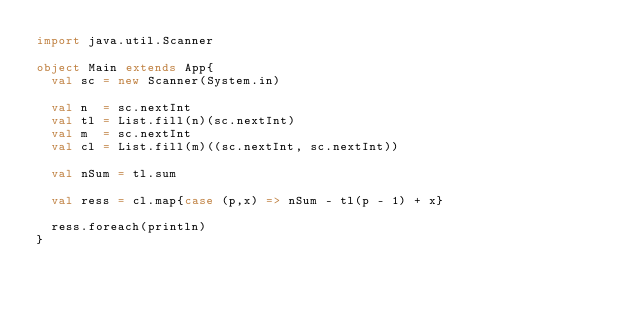Convert code to text. <code><loc_0><loc_0><loc_500><loc_500><_Scala_>import java.util.Scanner

object Main extends App{
  val sc = new Scanner(System.in)

  val n  = sc.nextInt
  val tl = List.fill(n)(sc.nextInt)
  val m  = sc.nextInt
  val cl = List.fill(m)((sc.nextInt, sc.nextInt))

  val nSum = tl.sum

  val ress = cl.map{case (p,x) => nSum - tl(p - 1) + x}

  ress.foreach(println)
}
</code> 